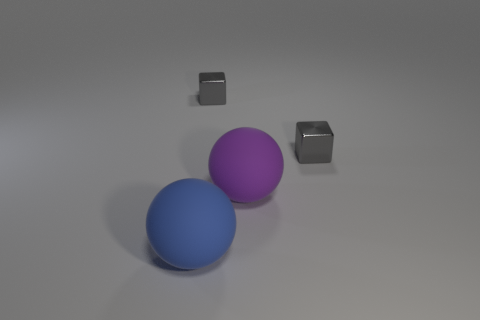Are the big ball left of the purple matte object and the big purple sphere made of the same material? Although the big ball to the left of the purple matte object and the big purple sphere share a similar matte appearance, without additional information on their composition, we can't conclusively determine if they are made of the exact same material. Factors such as weight, texture, and context could provide more insights into this. 